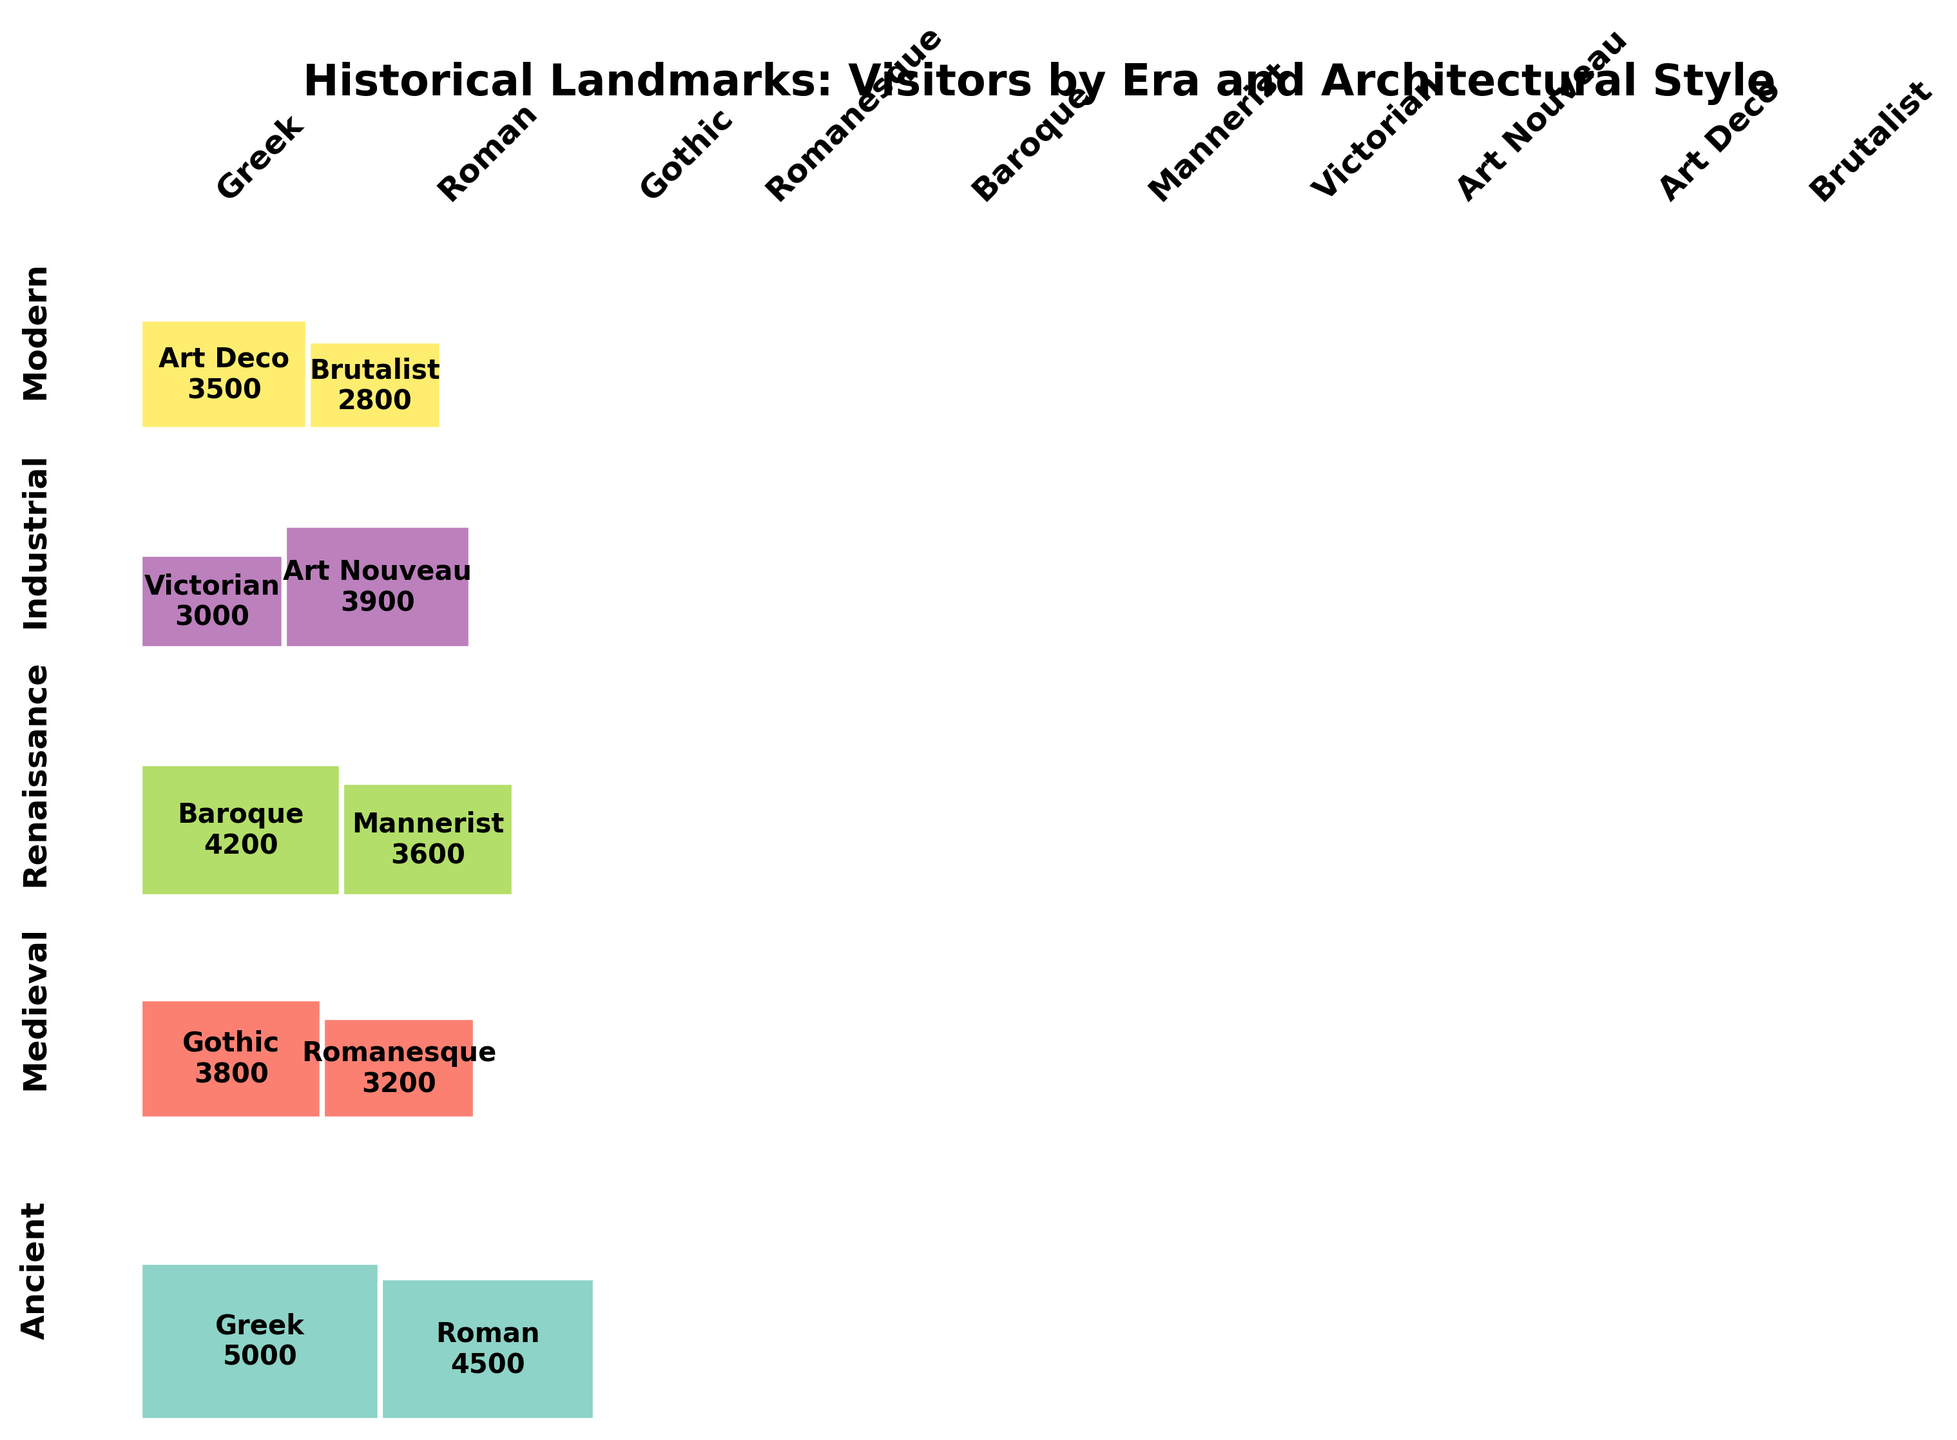What's the title of the figure? The title of the figure is typically found at the top of the plot. In this case, it's indicated within the plotting code provided.
Answer: Historical Landmarks: Visitors by Era and Architectural Style Which era has the highest number of visitors? To find this, look for the largest section in the vertical dimension, which indicates the total number of visitors per era.
Answer: Ancient Which architectural style received the most visitors? Identify the largest section in the horizontal dimension, indicating the total number of visitors per style.
Answer: Greek What is the architectural style with the least visitors in the Modern era? Look within the section marked "Modern" and compare the width of the two styles' sections. The smallest section represents the style with the least visitors.
Answer: Brutalist How many visitors did the Tower of London receive? Find the section corresponding to the Tower of London's unique pairing of "Medieval" era and "Romanesque" style, and look at the number listed on it.
Answer: 3200 Compare the number of visitors between the most and least popular landmarks. What is the difference? Identify the landmark with the highest and lowest visitor numbers from the plot, find their corresponding values, and subtract the lower from the higher.
Answer: 5000 - 2800 = 2200 Which era has the most architectural diversity in terms of style, and what are the styles? Check each era to see which one is divided into the most distinct segments horizontally. Then, identify and list these styles.
Answer: Medieval, Gothic and Romanesque How does the number of visitors to the Colosseum compare to the Notre-Dame Cathedral? Find the sections for the Colosseum and the Notre-Dame Cathedral, and compare their visitor numbers directly.
Answer: 4500 vs 3800 What proportion of total visitors did the Industrial era landmarks receive? Find the total number of visitors for the Industrial era from the plot, and divide by the total number of visitors shown at the bottom of the code.
Answer: (3000 + 3900) / 42500 ≈ 0.161 Which landmark had the fewest visitors in the Renaissance era, and how many? Within the Renaissance section, identify the style with the smaller segment, which indicates fewer visitors.
Answer: Palace of Versailles, 3600 